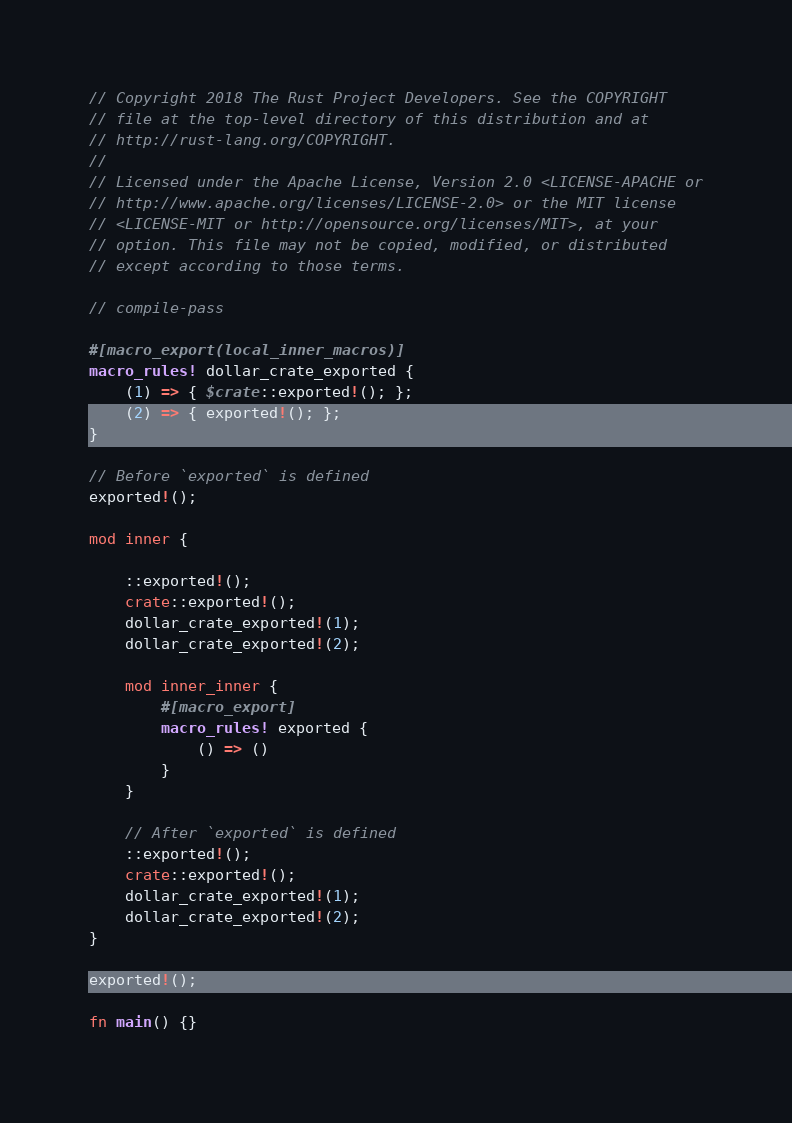<code> <loc_0><loc_0><loc_500><loc_500><_Rust_>// Copyright 2018 The Rust Project Developers. See the COPYRIGHT
// file at the top-level directory of this distribution and at
// http://rust-lang.org/COPYRIGHT.
//
// Licensed under the Apache License, Version 2.0 <LICENSE-APACHE or
// http://www.apache.org/licenses/LICENSE-2.0> or the MIT license
// <LICENSE-MIT or http://opensource.org/licenses/MIT>, at your
// option. This file may not be copied, modified, or distributed
// except according to those terms.

// compile-pass

#[macro_export(local_inner_macros)]
macro_rules! dollar_crate_exported {
    (1) => { $crate::exported!(); };
    (2) => { exported!(); };
}

// Before `exported` is defined
exported!();

mod inner {

    ::exported!();
    crate::exported!();
    dollar_crate_exported!(1);
    dollar_crate_exported!(2);

    mod inner_inner {
        #[macro_export]
        macro_rules! exported {
            () => ()
        }
    }

    // After `exported` is defined
    ::exported!();
    crate::exported!();
    dollar_crate_exported!(1);
    dollar_crate_exported!(2);
}

exported!();

fn main() {}
</code> 